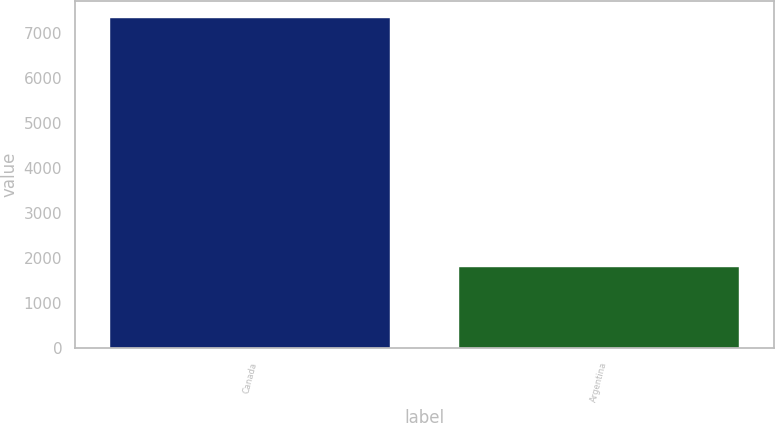<chart> <loc_0><loc_0><loc_500><loc_500><bar_chart><fcel>Canada<fcel>Argentina<nl><fcel>7344<fcel>1787<nl></chart> 